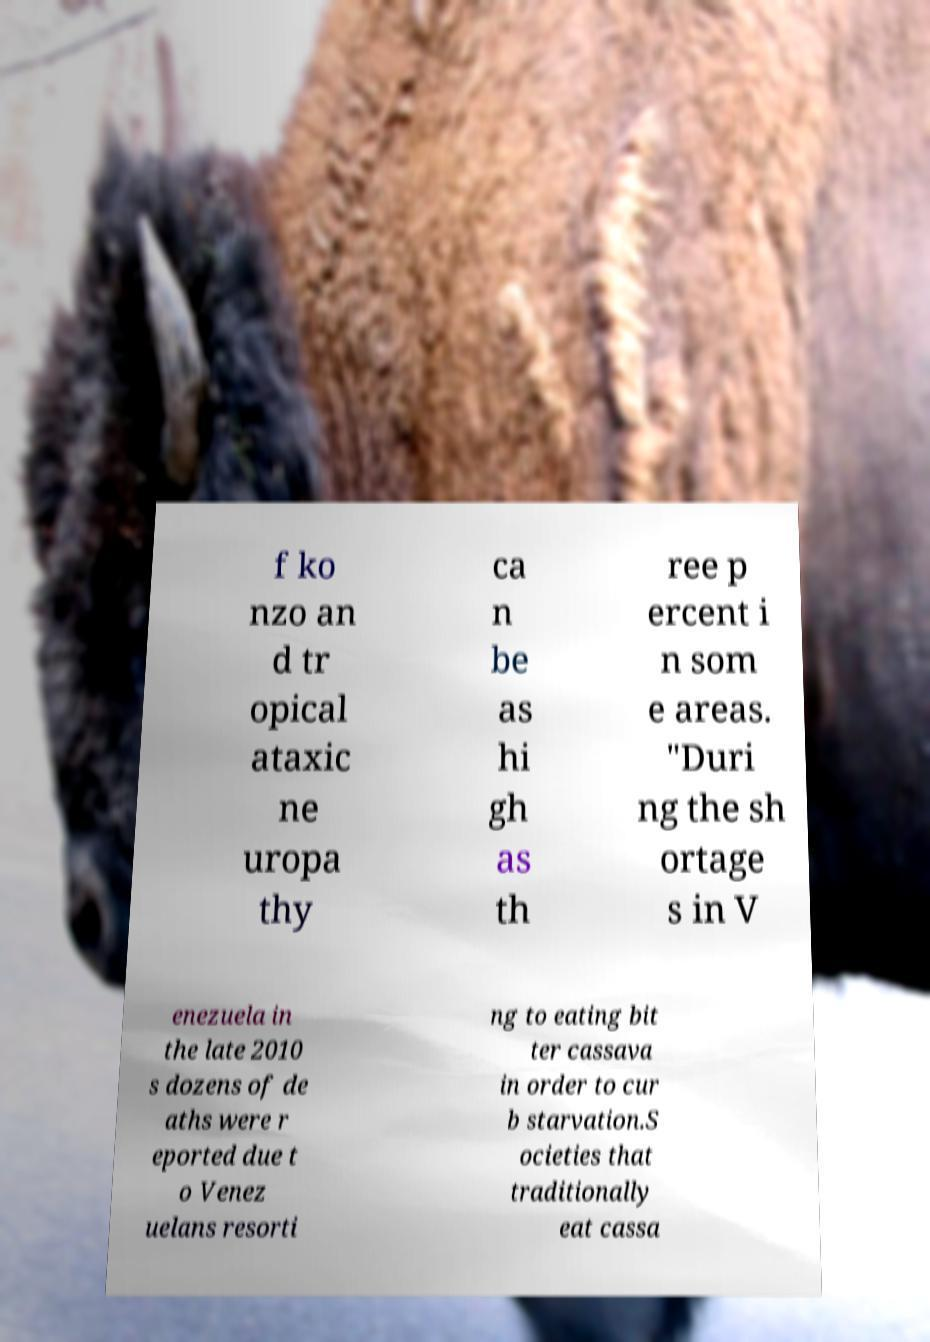For documentation purposes, I need the text within this image transcribed. Could you provide that? f ko nzo an d tr opical ataxic ne uropa thy ca n be as hi gh as th ree p ercent i n som e areas. "Duri ng the sh ortage s in V enezuela in the late 2010 s dozens of de aths were r eported due t o Venez uelans resorti ng to eating bit ter cassava in order to cur b starvation.S ocieties that traditionally eat cassa 